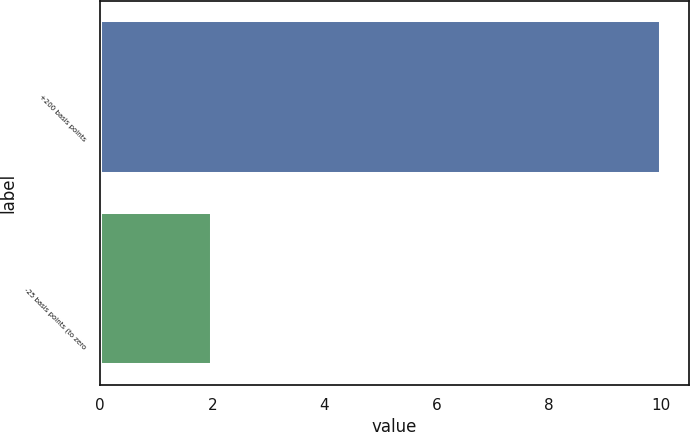Convert chart. <chart><loc_0><loc_0><loc_500><loc_500><bar_chart><fcel>+200 basis points<fcel>-25 basis points (to zero<nl><fcel>10<fcel>2<nl></chart> 